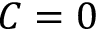Convert formula to latex. <formula><loc_0><loc_0><loc_500><loc_500>C = 0</formula> 